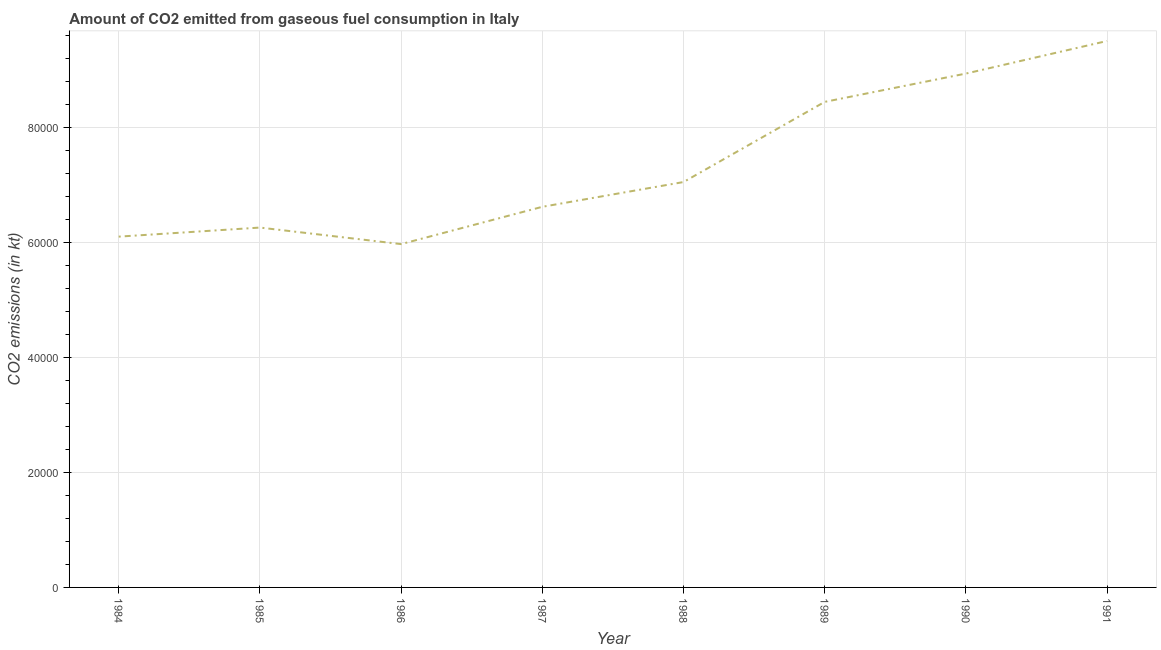What is the co2 emissions from gaseous fuel consumption in 1986?
Your answer should be very brief. 5.97e+04. Across all years, what is the maximum co2 emissions from gaseous fuel consumption?
Provide a short and direct response. 9.50e+04. Across all years, what is the minimum co2 emissions from gaseous fuel consumption?
Ensure brevity in your answer.  5.97e+04. In which year was the co2 emissions from gaseous fuel consumption minimum?
Your response must be concise. 1986. What is the sum of the co2 emissions from gaseous fuel consumption?
Provide a short and direct response. 5.89e+05. What is the difference between the co2 emissions from gaseous fuel consumption in 1985 and 1990?
Provide a succinct answer. -2.68e+04. What is the average co2 emissions from gaseous fuel consumption per year?
Offer a terse response. 7.36e+04. What is the median co2 emissions from gaseous fuel consumption?
Make the answer very short. 6.83e+04. In how many years, is the co2 emissions from gaseous fuel consumption greater than 92000 kt?
Offer a very short reply. 1. Do a majority of the years between 1989 and 1988 (inclusive) have co2 emissions from gaseous fuel consumption greater than 64000 kt?
Your answer should be very brief. No. What is the ratio of the co2 emissions from gaseous fuel consumption in 1988 to that in 1990?
Offer a terse response. 0.79. Is the co2 emissions from gaseous fuel consumption in 1984 less than that in 1989?
Give a very brief answer. Yes. What is the difference between the highest and the second highest co2 emissions from gaseous fuel consumption?
Your answer should be compact. 5665.51. Is the sum of the co2 emissions from gaseous fuel consumption in 1985 and 1988 greater than the maximum co2 emissions from gaseous fuel consumption across all years?
Your answer should be very brief. Yes. What is the difference between the highest and the lowest co2 emissions from gaseous fuel consumption?
Ensure brevity in your answer.  3.53e+04. In how many years, is the co2 emissions from gaseous fuel consumption greater than the average co2 emissions from gaseous fuel consumption taken over all years?
Your answer should be compact. 3. How many years are there in the graph?
Your response must be concise. 8. Are the values on the major ticks of Y-axis written in scientific E-notation?
Give a very brief answer. No. Does the graph contain grids?
Offer a terse response. Yes. What is the title of the graph?
Ensure brevity in your answer.  Amount of CO2 emitted from gaseous fuel consumption in Italy. What is the label or title of the X-axis?
Provide a short and direct response. Year. What is the label or title of the Y-axis?
Give a very brief answer. CO2 emissions (in kt). What is the CO2 emissions (in kt) of 1984?
Make the answer very short. 6.10e+04. What is the CO2 emissions (in kt) in 1985?
Your answer should be very brief. 6.26e+04. What is the CO2 emissions (in kt) in 1986?
Offer a very short reply. 5.97e+04. What is the CO2 emissions (in kt) of 1987?
Keep it short and to the point. 6.62e+04. What is the CO2 emissions (in kt) of 1988?
Ensure brevity in your answer.  7.05e+04. What is the CO2 emissions (in kt) in 1989?
Keep it short and to the point. 8.44e+04. What is the CO2 emissions (in kt) of 1990?
Offer a terse response. 8.93e+04. What is the CO2 emissions (in kt) in 1991?
Provide a short and direct response. 9.50e+04. What is the difference between the CO2 emissions (in kt) in 1984 and 1985?
Give a very brief answer. -1576.81. What is the difference between the CO2 emissions (in kt) in 1984 and 1986?
Your response must be concise. 1298.12. What is the difference between the CO2 emissions (in kt) in 1984 and 1987?
Your answer should be compact. -5185.14. What is the difference between the CO2 emissions (in kt) in 1984 and 1988?
Offer a very short reply. -9490.2. What is the difference between the CO2 emissions (in kt) in 1984 and 1989?
Provide a short and direct response. -2.34e+04. What is the difference between the CO2 emissions (in kt) in 1984 and 1990?
Make the answer very short. -2.83e+04. What is the difference between the CO2 emissions (in kt) in 1984 and 1991?
Make the answer very short. -3.40e+04. What is the difference between the CO2 emissions (in kt) in 1985 and 1986?
Ensure brevity in your answer.  2874.93. What is the difference between the CO2 emissions (in kt) in 1985 and 1987?
Ensure brevity in your answer.  -3608.33. What is the difference between the CO2 emissions (in kt) in 1985 and 1988?
Provide a succinct answer. -7913.39. What is the difference between the CO2 emissions (in kt) in 1985 and 1989?
Your answer should be very brief. -2.18e+04. What is the difference between the CO2 emissions (in kt) in 1985 and 1990?
Provide a short and direct response. -2.68e+04. What is the difference between the CO2 emissions (in kt) in 1985 and 1991?
Provide a short and direct response. -3.24e+04. What is the difference between the CO2 emissions (in kt) in 1986 and 1987?
Your response must be concise. -6483.26. What is the difference between the CO2 emissions (in kt) in 1986 and 1988?
Ensure brevity in your answer.  -1.08e+04. What is the difference between the CO2 emissions (in kt) in 1986 and 1989?
Provide a succinct answer. -2.47e+04. What is the difference between the CO2 emissions (in kt) in 1986 and 1990?
Make the answer very short. -2.96e+04. What is the difference between the CO2 emissions (in kt) in 1986 and 1991?
Provide a short and direct response. -3.53e+04. What is the difference between the CO2 emissions (in kt) in 1987 and 1988?
Provide a succinct answer. -4305.06. What is the difference between the CO2 emissions (in kt) in 1987 and 1989?
Offer a terse response. -1.82e+04. What is the difference between the CO2 emissions (in kt) in 1987 and 1990?
Keep it short and to the point. -2.32e+04. What is the difference between the CO2 emissions (in kt) in 1987 and 1991?
Provide a short and direct response. -2.88e+04. What is the difference between the CO2 emissions (in kt) in 1988 and 1989?
Offer a very short reply. -1.39e+04. What is the difference between the CO2 emissions (in kt) in 1988 and 1990?
Your answer should be compact. -1.89e+04. What is the difference between the CO2 emissions (in kt) in 1988 and 1991?
Ensure brevity in your answer.  -2.45e+04. What is the difference between the CO2 emissions (in kt) in 1989 and 1990?
Offer a very short reply. -4921.11. What is the difference between the CO2 emissions (in kt) in 1989 and 1991?
Provide a succinct answer. -1.06e+04. What is the difference between the CO2 emissions (in kt) in 1990 and 1991?
Offer a very short reply. -5665.52. What is the ratio of the CO2 emissions (in kt) in 1984 to that in 1985?
Your response must be concise. 0.97. What is the ratio of the CO2 emissions (in kt) in 1984 to that in 1986?
Your response must be concise. 1.02. What is the ratio of the CO2 emissions (in kt) in 1984 to that in 1987?
Offer a terse response. 0.92. What is the ratio of the CO2 emissions (in kt) in 1984 to that in 1988?
Your response must be concise. 0.86. What is the ratio of the CO2 emissions (in kt) in 1984 to that in 1989?
Offer a terse response. 0.72. What is the ratio of the CO2 emissions (in kt) in 1984 to that in 1990?
Your answer should be very brief. 0.68. What is the ratio of the CO2 emissions (in kt) in 1984 to that in 1991?
Provide a short and direct response. 0.64. What is the ratio of the CO2 emissions (in kt) in 1985 to that in 1986?
Offer a very short reply. 1.05. What is the ratio of the CO2 emissions (in kt) in 1985 to that in 1987?
Keep it short and to the point. 0.94. What is the ratio of the CO2 emissions (in kt) in 1985 to that in 1988?
Keep it short and to the point. 0.89. What is the ratio of the CO2 emissions (in kt) in 1985 to that in 1989?
Your answer should be compact. 0.74. What is the ratio of the CO2 emissions (in kt) in 1985 to that in 1991?
Offer a terse response. 0.66. What is the ratio of the CO2 emissions (in kt) in 1986 to that in 1987?
Your response must be concise. 0.9. What is the ratio of the CO2 emissions (in kt) in 1986 to that in 1988?
Provide a succinct answer. 0.85. What is the ratio of the CO2 emissions (in kt) in 1986 to that in 1989?
Ensure brevity in your answer.  0.71. What is the ratio of the CO2 emissions (in kt) in 1986 to that in 1990?
Your response must be concise. 0.67. What is the ratio of the CO2 emissions (in kt) in 1986 to that in 1991?
Offer a very short reply. 0.63. What is the ratio of the CO2 emissions (in kt) in 1987 to that in 1988?
Ensure brevity in your answer.  0.94. What is the ratio of the CO2 emissions (in kt) in 1987 to that in 1989?
Ensure brevity in your answer.  0.78. What is the ratio of the CO2 emissions (in kt) in 1987 to that in 1990?
Keep it short and to the point. 0.74. What is the ratio of the CO2 emissions (in kt) in 1987 to that in 1991?
Provide a short and direct response. 0.7. What is the ratio of the CO2 emissions (in kt) in 1988 to that in 1989?
Ensure brevity in your answer.  0.83. What is the ratio of the CO2 emissions (in kt) in 1988 to that in 1990?
Give a very brief answer. 0.79. What is the ratio of the CO2 emissions (in kt) in 1988 to that in 1991?
Keep it short and to the point. 0.74. What is the ratio of the CO2 emissions (in kt) in 1989 to that in 1990?
Your answer should be compact. 0.94. What is the ratio of the CO2 emissions (in kt) in 1989 to that in 1991?
Your answer should be compact. 0.89. What is the ratio of the CO2 emissions (in kt) in 1990 to that in 1991?
Ensure brevity in your answer.  0.94. 